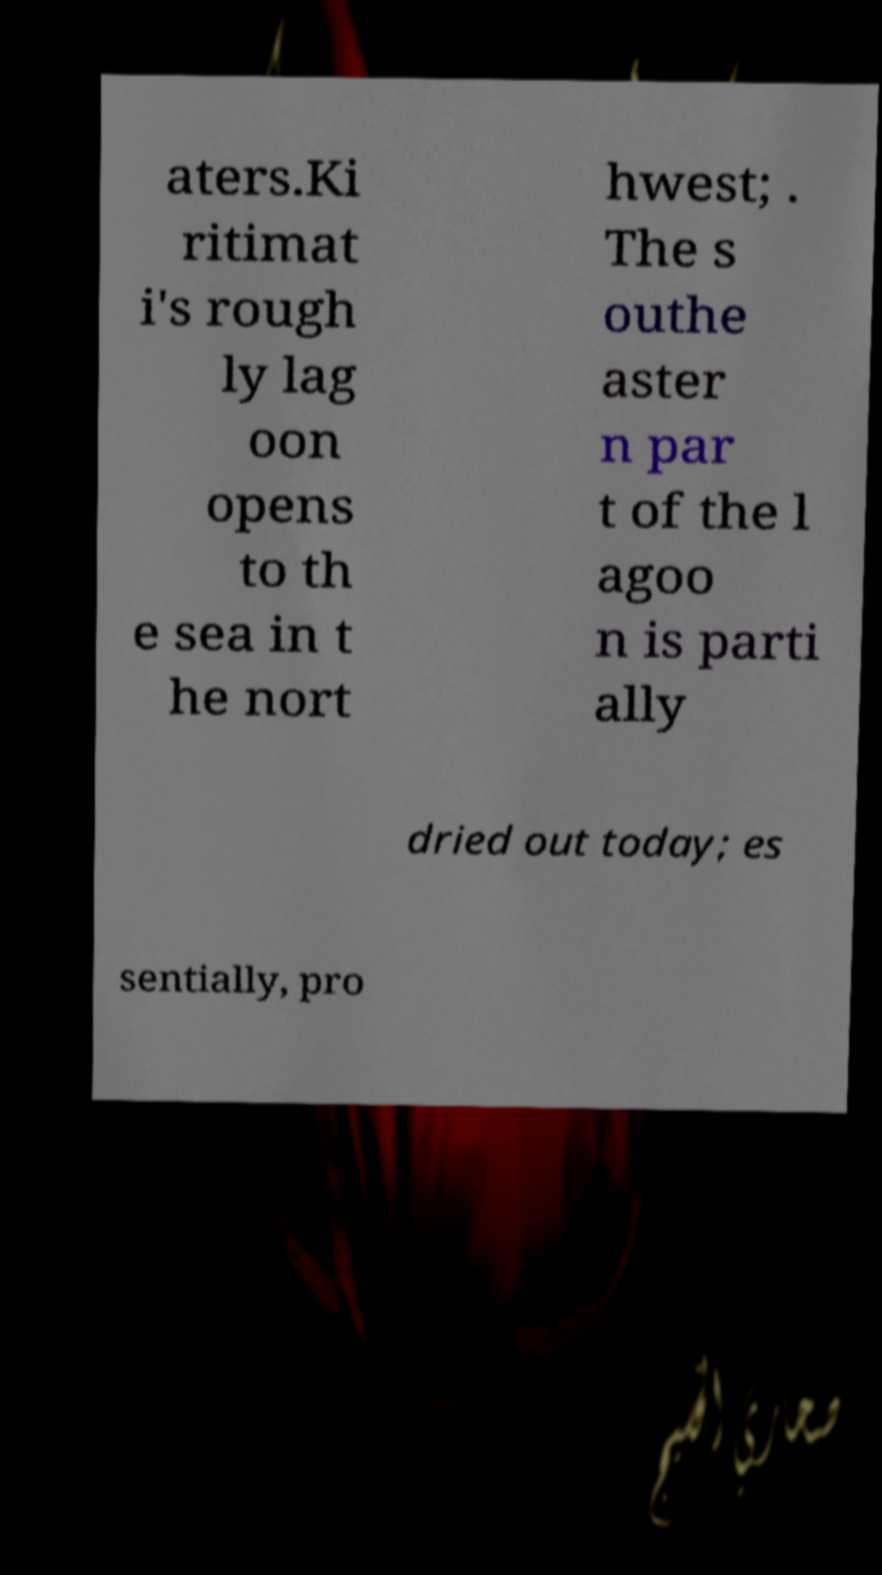There's text embedded in this image that I need extracted. Can you transcribe it verbatim? aters.Ki ritimat i's rough ly lag oon opens to th e sea in t he nort hwest; . The s outhe aster n par t of the l agoo n is parti ally dried out today; es sentially, pro 